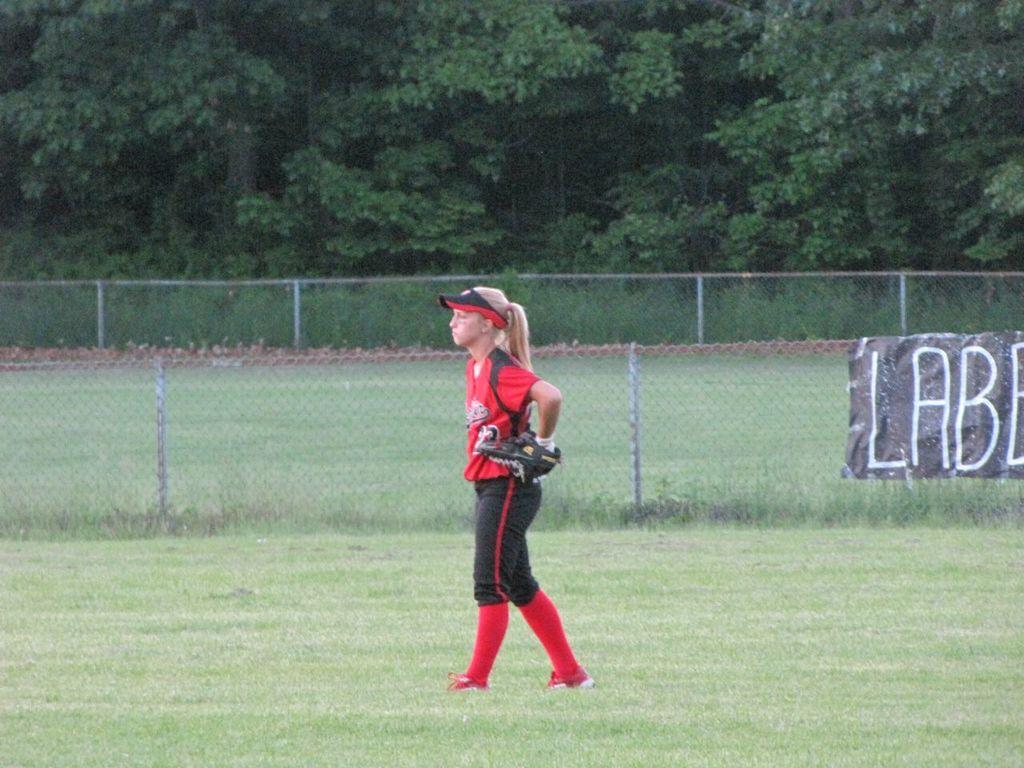What does the sign say, in white and black, behind the athlete?
Your response must be concise. Lab. What number is her jersey?
Provide a short and direct response. 23. 